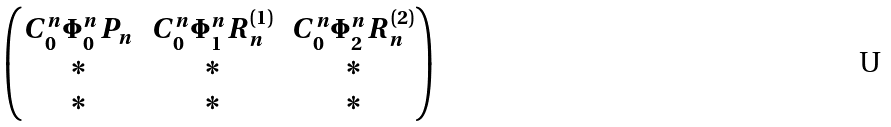Convert formula to latex. <formula><loc_0><loc_0><loc_500><loc_500>\begin{pmatrix} C _ { 0 } ^ { n } \Phi _ { 0 } ^ { n } P _ { n } & C _ { 0 } ^ { n } \Phi _ { 1 } ^ { n } R _ { n } ^ { ( 1 ) } & C _ { 0 } ^ { n } \Phi _ { 2 } ^ { n } R _ { n } ^ { ( 2 ) } \\ * & * & * \\ * & * & * \end{pmatrix}</formula> 